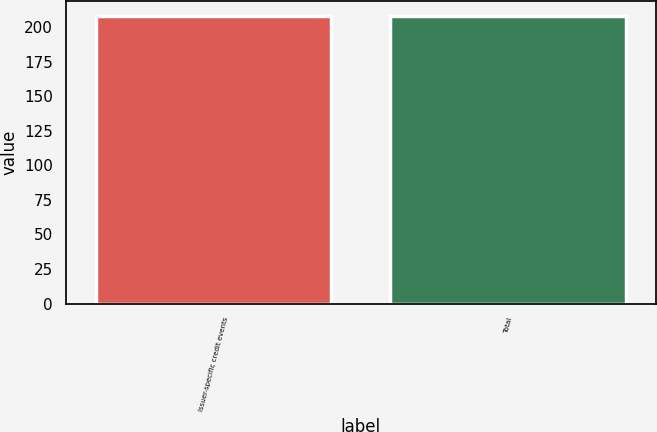Convert chart to OTSL. <chart><loc_0><loc_0><loc_500><loc_500><bar_chart><fcel>Issuer-specific credit events<fcel>Total<nl><fcel>208<fcel>208.1<nl></chart> 